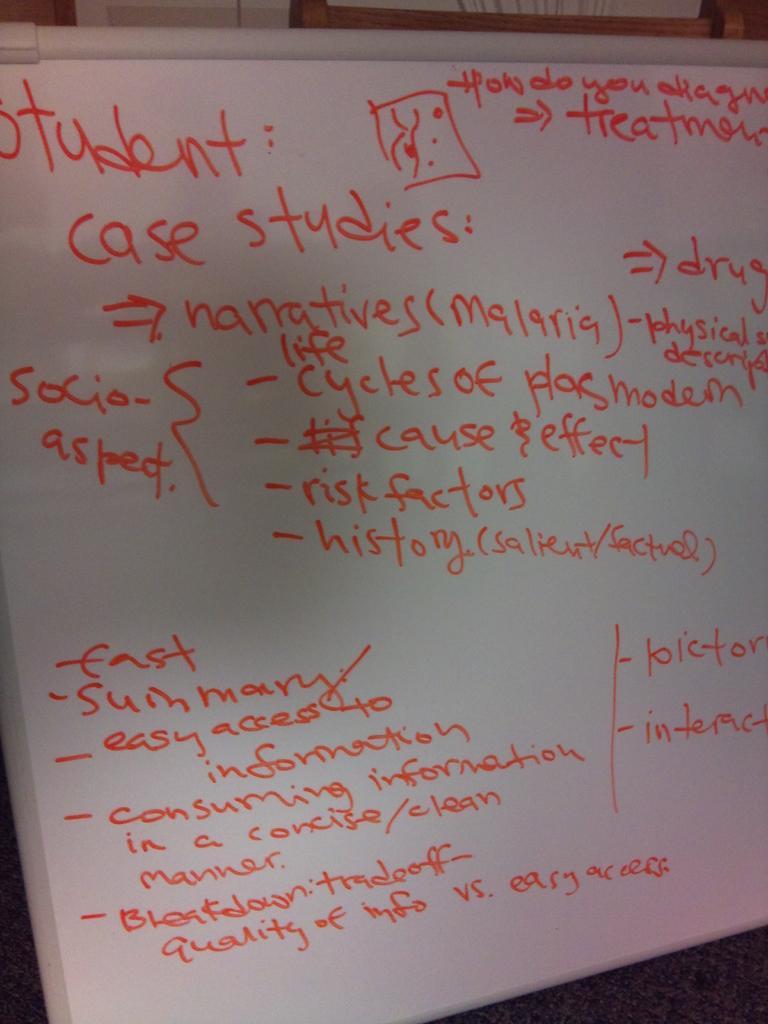Can you describe this image briefly? In this image there is a white board on which there is some text. 